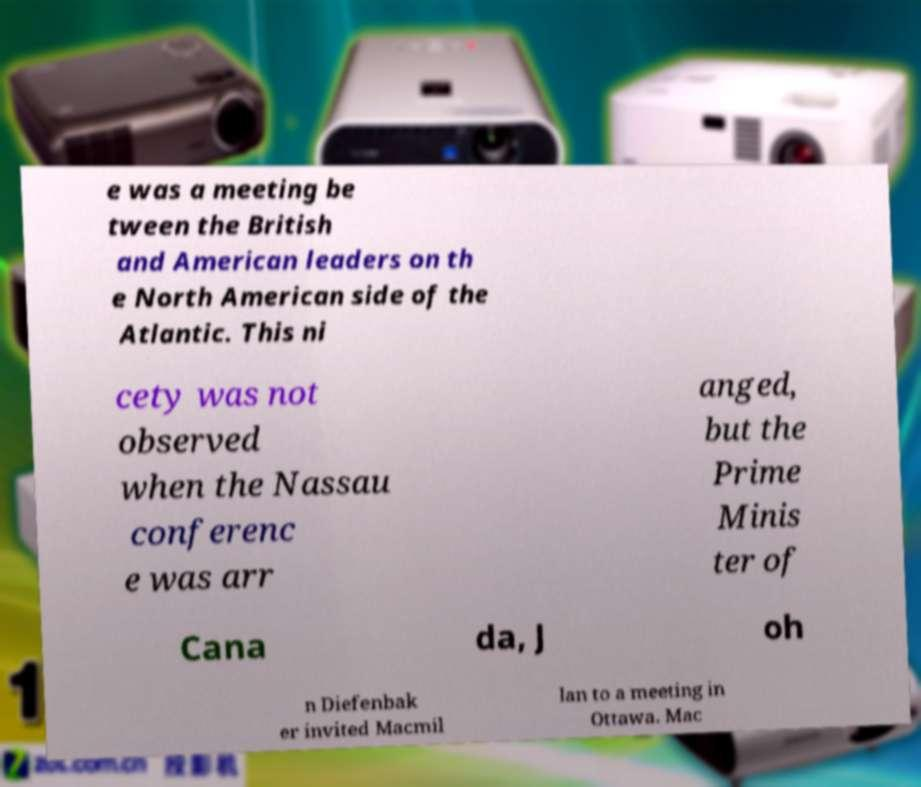Please read and relay the text visible in this image. What does it say? e was a meeting be tween the British and American leaders on th e North American side of the Atlantic. This ni cety was not observed when the Nassau conferenc e was arr anged, but the Prime Minis ter of Cana da, J oh n Diefenbak er invited Macmil lan to a meeting in Ottawa. Mac 